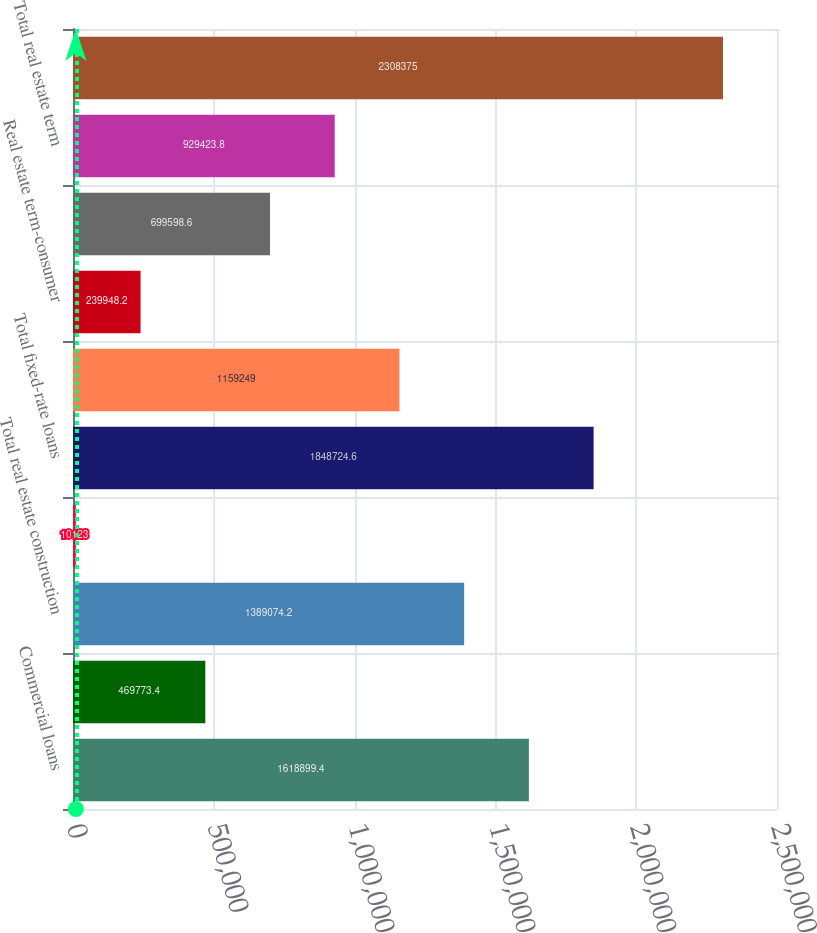Convert chart to OTSL. <chart><loc_0><loc_0><loc_500><loc_500><bar_chart><fcel>Commercial loans<fcel>Commercial real estate<fcel>Total real estate construction<fcel>Consumer and other<fcel>Total fixed-rate loans<fcel>Vineyard development<fcel>Real estate term-consumer<fcel>Real estate term-commercial<fcel>Total real estate term<fcel>Total variable-rate loans<nl><fcel>1.6189e+06<fcel>469773<fcel>1.38907e+06<fcel>10123<fcel>1.84872e+06<fcel>1.15925e+06<fcel>239948<fcel>699599<fcel>929424<fcel>2.30838e+06<nl></chart> 